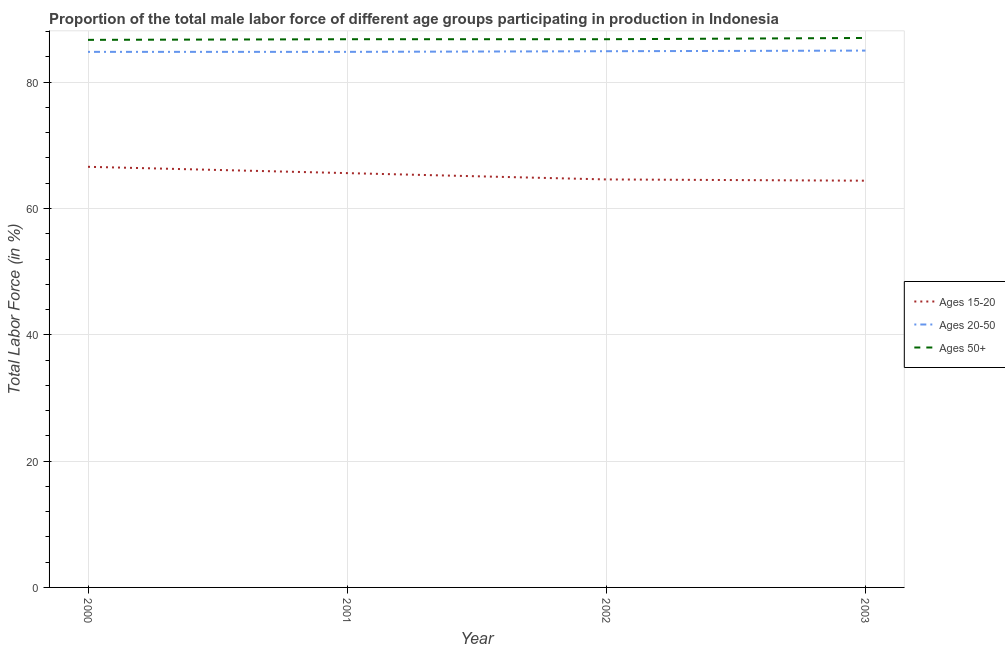Does the line corresponding to percentage of male labor force within the age group 15-20 intersect with the line corresponding to percentage of male labor force within the age group 20-50?
Make the answer very short. No. Is the number of lines equal to the number of legend labels?
Your answer should be very brief. Yes. What is the percentage of male labor force within the age group 15-20 in 2001?
Your answer should be very brief. 65.6. Across all years, what is the maximum percentage of male labor force above age 50?
Your answer should be very brief. 87. Across all years, what is the minimum percentage of male labor force within the age group 20-50?
Ensure brevity in your answer.  84.8. What is the total percentage of male labor force within the age group 20-50 in the graph?
Offer a very short reply. 339.5. What is the average percentage of male labor force above age 50 per year?
Keep it short and to the point. 86.83. In the year 2000, what is the difference between the percentage of male labor force within the age group 15-20 and percentage of male labor force above age 50?
Offer a terse response. -20.1. In how many years, is the percentage of male labor force within the age group 20-50 greater than 12 %?
Your response must be concise. 4. Is the percentage of male labor force within the age group 20-50 in 2000 less than that in 2003?
Offer a terse response. Yes. What is the difference between the highest and the second highest percentage of male labor force within the age group 20-50?
Your answer should be very brief. 0.1. What is the difference between the highest and the lowest percentage of male labor force above age 50?
Offer a terse response. 0.3. In how many years, is the percentage of male labor force within the age group 20-50 greater than the average percentage of male labor force within the age group 20-50 taken over all years?
Ensure brevity in your answer.  2. Is the sum of the percentage of male labor force above age 50 in 2000 and 2002 greater than the maximum percentage of male labor force within the age group 15-20 across all years?
Make the answer very short. Yes. Is it the case that in every year, the sum of the percentage of male labor force within the age group 15-20 and percentage of male labor force within the age group 20-50 is greater than the percentage of male labor force above age 50?
Give a very brief answer. Yes. Does the percentage of male labor force above age 50 monotonically increase over the years?
Your answer should be compact. No. Is the percentage of male labor force within the age group 20-50 strictly greater than the percentage of male labor force within the age group 15-20 over the years?
Keep it short and to the point. Yes. How many lines are there?
Your answer should be compact. 3. How many years are there in the graph?
Offer a terse response. 4. Are the values on the major ticks of Y-axis written in scientific E-notation?
Your answer should be compact. No. Does the graph contain any zero values?
Offer a terse response. No. Does the graph contain grids?
Your answer should be compact. Yes. Where does the legend appear in the graph?
Keep it short and to the point. Center right. How many legend labels are there?
Your answer should be compact. 3. What is the title of the graph?
Offer a very short reply. Proportion of the total male labor force of different age groups participating in production in Indonesia. Does "Manufactures" appear as one of the legend labels in the graph?
Offer a very short reply. No. What is the Total Labor Force (in %) of Ages 15-20 in 2000?
Your response must be concise. 66.6. What is the Total Labor Force (in %) in Ages 20-50 in 2000?
Your answer should be very brief. 84.8. What is the Total Labor Force (in %) in Ages 50+ in 2000?
Your answer should be compact. 86.7. What is the Total Labor Force (in %) of Ages 15-20 in 2001?
Offer a terse response. 65.6. What is the Total Labor Force (in %) of Ages 20-50 in 2001?
Ensure brevity in your answer.  84.8. What is the Total Labor Force (in %) of Ages 50+ in 2001?
Your answer should be compact. 86.8. What is the Total Labor Force (in %) in Ages 15-20 in 2002?
Your answer should be very brief. 64.6. What is the Total Labor Force (in %) in Ages 20-50 in 2002?
Keep it short and to the point. 84.9. What is the Total Labor Force (in %) of Ages 50+ in 2002?
Your response must be concise. 86.8. What is the Total Labor Force (in %) in Ages 15-20 in 2003?
Give a very brief answer. 64.4. What is the Total Labor Force (in %) in Ages 50+ in 2003?
Provide a short and direct response. 87. Across all years, what is the maximum Total Labor Force (in %) of Ages 15-20?
Provide a succinct answer. 66.6. Across all years, what is the minimum Total Labor Force (in %) in Ages 15-20?
Your answer should be compact. 64.4. Across all years, what is the minimum Total Labor Force (in %) in Ages 20-50?
Make the answer very short. 84.8. Across all years, what is the minimum Total Labor Force (in %) in Ages 50+?
Provide a short and direct response. 86.7. What is the total Total Labor Force (in %) in Ages 15-20 in the graph?
Provide a succinct answer. 261.2. What is the total Total Labor Force (in %) in Ages 20-50 in the graph?
Offer a very short reply. 339.5. What is the total Total Labor Force (in %) of Ages 50+ in the graph?
Your response must be concise. 347.3. What is the difference between the Total Labor Force (in %) of Ages 50+ in 2000 and that in 2002?
Provide a short and direct response. -0.1. What is the difference between the Total Labor Force (in %) in Ages 50+ in 2000 and that in 2003?
Offer a very short reply. -0.3. What is the difference between the Total Labor Force (in %) in Ages 50+ in 2001 and that in 2003?
Keep it short and to the point. -0.2. What is the difference between the Total Labor Force (in %) of Ages 50+ in 2002 and that in 2003?
Make the answer very short. -0.2. What is the difference between the Total Labor Force (in %) of Ages 15-20 in 2000 and the Total Labor Force (in %) of Ages 20-50 in 2001?
Provide a short and direct response. -18.2. What is the difference between the Total Labor Force (in %) in Ages 15-20 in 2000 and the Total Labor Force (in %) in Ages 50+ in 2001?
Provide a short and direct response. -20.2. What is the difference between the Total Labor Force (in %) in Ages 15-20 in 2000 and the Total Labor Force (in %) in Ages 20-50 in 2002?
Your answer should be very brief. -18.3. What is the difference between the Total Labor Force (in %) in Ages 15-20 in 2000 and the Total Labor Force (in %) in Ages 50+ in 2002?
Offer a very short reply. -20.2. What is the difference between the Total Labor Force (in %) of Ages 15-20 in 2000 and the Total Labor Force (in %) of Ages 20-50 in 2003?
Your response must be concise. -18.4. What is the difference between the Total Labor Force (in %) of Ages 15-20 in 2000 and the Total Labor Force (in %) of Ages 50+ in 2003?
Offer a very short reply. -20.4. What is the difference between the Total Labor Force (in %) of Ages 20-50 in 2000 and the Total Labor Force (in %) of Ages 50+ in 2003?
Offer a very short reply. -2.2. What is the difference between the Total Labor Force (in %) in Ages 15-20 in 2001 and the Total Labor Force (in %) in Ages 20-50 in 2002?
Your answer should be very brief. -19.3. What is the difference between the Total Labor Force (in %) of Ages 15-20 in 2001 and the Total Labor Force (in %) of Ages 50+ in 2002?
Ensure brevity in your answer.  -21.2. What is the difference between the Total Labor Force (in %) in Ages 20-50 in 2001 and the Total Labor Force (in %) in Ages 50+ in 2002?
Make the answer very short. -2. What is the difference between the Total Labor Force (in %) of Ages 15-20 in 2001 and the Total Labor Force (in %) of Ages 20-50 in 2003?
Ensure brevity in your answer.  -19.4. What is the difference between the Total Labor Force (in %) of Ages 15-20 in 2001 and the Total Labor Force (in %) of Ages 50+ in 2003?
Keep it short and to the point. -21.4. What is the difference between the Total Labor Force (in %) in Ages 20-50 in 2001 and the Total Labor Force (in %) in Ages 50+ in 2003?
Offer a very short reply. -2.2. What is the difference between the Total Labor Force (in %) in Ages 15-20 in 2002 and the Total Labor Force (in %) in Ages 20-50 in 2003?
Your answer should be compact. -20.4. What is the difference between the Total Labor Force (in %) in Ages 15-20 in 2002 and the Total Labor Force (in %) in Ages 50+ in 2003?
Your response must be concise. -22.4. What is the average Total Labor Force (in %) of Ages 15-20 per year?
Offer a terse response. 65.3. What is the average Total Labor Force (in %) in Ages 20-50 per year?
Your answer should be very brief. 84.88. What is the average Total Labor Force (in %) in Ages 50+ per year?
Your response must be concise. 86.83. In the year 2000, what is the difference between the Total Labor Force (in %) in Ages 15-20 and Total Labor Force (in %) in Ages 20-50?
Offer a terse response. -18.2. In the year 2000, what is the difference between the Total Labor Force (in %) of Ages 15-20 and Total Labor Force (in %) of Ages 50+?
Offer a terse response. -20.1. In the year 2001, what is the difference between the Total Labor Force (in %) of Ages 15-20 and Total Labor Force (in %) of Ages 20-50?
Make the answer very short. -19.2. In the year 2001, what is the difference between the Total Labor Force (in %) of Ages 15-20 and Total Labor Force (in %) of Ages 50+?
Offer a terse response. -21.2. In the year 2002, what is the difference between the Total Labor Force (in %) of Ages 15-20 and Total Labor Force (in %) of Ages 20-50?
Your answer should be very brief. -20.3. In the year 2002, what is the difference between the Total Labor Force (in %) in Ages 15-20 and Total Labor Force (in %) in Ages 50+?
Your response must be concise. -22.2. In the year 2003, what is the difference between the Total Labor Force (in %) in Ages 15-20 and Total Labor Force (in %) in Ages 20-50?
Your answer should be compact. -20.6. In the year 2003, what is the difference between the Total Labor Force (in %) of Ages 15-20 and Total Labor Force (in %) of Ages 50+?
Your response must be concise. -22.6. In the year 2003, what is the difference between the Total Labor Force (in %) of Ages 20-50 and Total Labor Force (in %) of Ages 50+?
Provide a succinct answer. -2. What is the ratio of the Total Labor Force (in %) of Ages 15-20 in 2000 to that in 2001?
Offer a terse response. 1.02. What is the ratio of the Total Labor Force (in %) of Ages 20-50 in 2000 to that in 2001?
Your answer should be compact. 1. What is the ratio of the Total Labor Force (in %) of Ages 15-20 in 2000 to that in 2002?
Provide a succinct answer. 1.03. What is the ratio of the Total Labor Force (in %) of Ages 20-50 in 2000 to that in 2002?
Offer a very short reply. 1. What is the ratio of the Total Labor Force (in %) of Ages 50+ in 2000 to that in 2002?
Provide a succinct answer. 1. What is the ratio of the Total Labor Force (in %) of Ages 15-20 in 2000 to that in 2003?
Provide a short and direct response. 1.03. What is the ratio of the Total Labor Force (in %) in Ages 15-20 in 2001 to that in 2002?
Make the answer very short. 1.02. What is the ratio of the Total Labor Force (in %) of Ages 50+ in 2001 to that in 2002?
Your response must be concise. 1. What is the ratio of the Total Labor Force (in %) in Ages 15-20 in 2001 to that in 2003?
Your answer should be very brief. 1.02. What is the ratio of the Total Labor Force (in %) in Ages 20-50 in 2001 to that in 2003?
Provide a succinct answer. 1. What is the ratio of the Total Labor Force (in %) in Ages 50+ in 2001 to that in 2003?
Provide a short and direct response. 1. What is the ratio of the Total Labor Force (in %) of Ages 50+ in 2002 to that in 2003?
Provide a short and direct response. 1. What is the difference between the highest and the second highest Total Labor Force (in %) of Ages 15-20?
Keep it short and to the point. 1. What is the difference between the highest and the second highest Total Labor Force (in %) in Ages 20-50?
Give a very brief answer. 0.1. What is the difference between the highest and the lowest Total Labor Force (in %) in Ages 15-20?
Keep it short and to the point. 2.2. What is the difference between the highest and the lowest Total Labor Force (in %) in Ages 20-50?
Give a very brief answer. 0.2. 